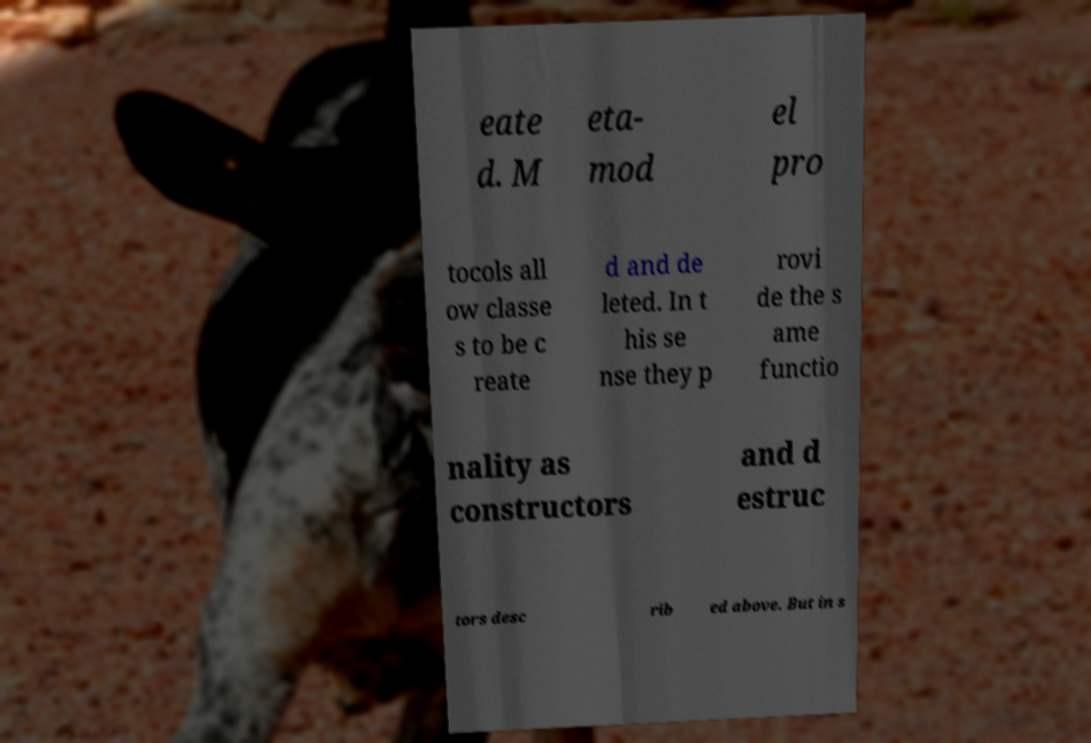Could you extract and type out the text from this image? eate d. M eta- mod el pro tocols all ow classe s to be c reate d and de leted. In t his se nse they p rovi de the s ame functio nality as constructors and d estruc tors desc rib ed above. But in s 